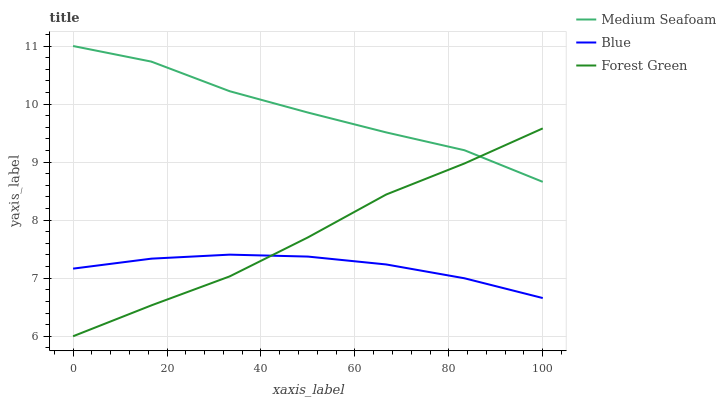Does Blue have the minimum area under the curve?
Answer yes or no. Yes. Does Medium Seafoam have the maximum area under the curve?
Answer yes or no. Yes. Does Forest Green have the minimum area under the curve?
Answer yes or no. No. Does Forest Green have the maximum area under the curve?
Answer yes or no. No. Is Blue the smoothest?
Answer yes or no. Yes. Is Medium Seafoam the roughest?
Answer yes or no. Yes. Is Forest Green the smoothest?
Answer yes or no. No. Is Forest Green the roughest?
Answer yes or no. No. Does Medium Seafoam have the lowest value?
Answer yes or no. No. Does Medium Seafoam have the highest value?
Answer yes or no. Yes. Does Forest Green have the highest value?
Answer yes or no. No. Is Blue less than Medium Seafoam?
Answer yes or no. Yes. Is Medium Seafoam greater than Blue?
Answer yes or no. Yes. Does Forest Green intersect Medium Seafoam?
Answer yes or no. Yes. Is Forest Green less than Medium Seafoam?
Answer yes or no. No. Is Forest Green greater than Medium Seafoam?
Answer yes or no. No. Does Blue intersect Medium Seafoam?
Answer yes or no. No. 